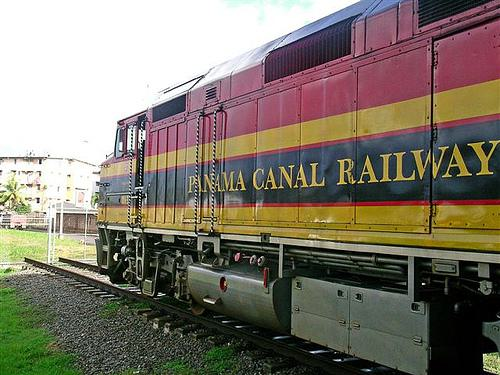Can you tell if the train is currently in motion? Based on the image, it is not easy to tell conclusively if the train is in motion; there are no clear motion blurs or other dynamic indicators. However, the position of the wheels on the track appears static, and there are no signs of exhaust or other motion effects, suggesting the train might be stationary at the moment the photo was taken. 